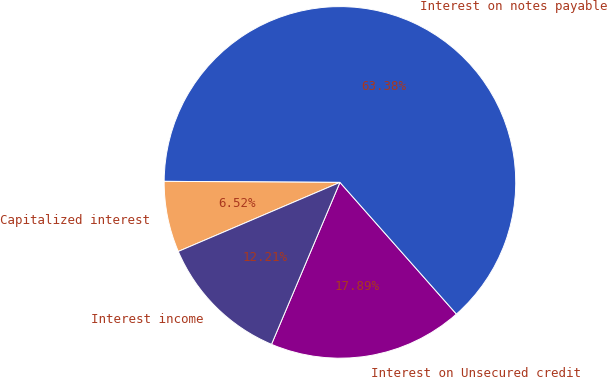Convert chart to OTSL. <chart><loc_0><loc_0><loc_500><loc_500><pie_chart><fcel>Interest on Unsecured credit<fcel>Interest on notes payable<fcel>Capitalized interest<fcel>Interest income<nl><fcel>17.89%<fcel>63.38%<fcel>6.52%<fcel>12.21%<nl></chart> 